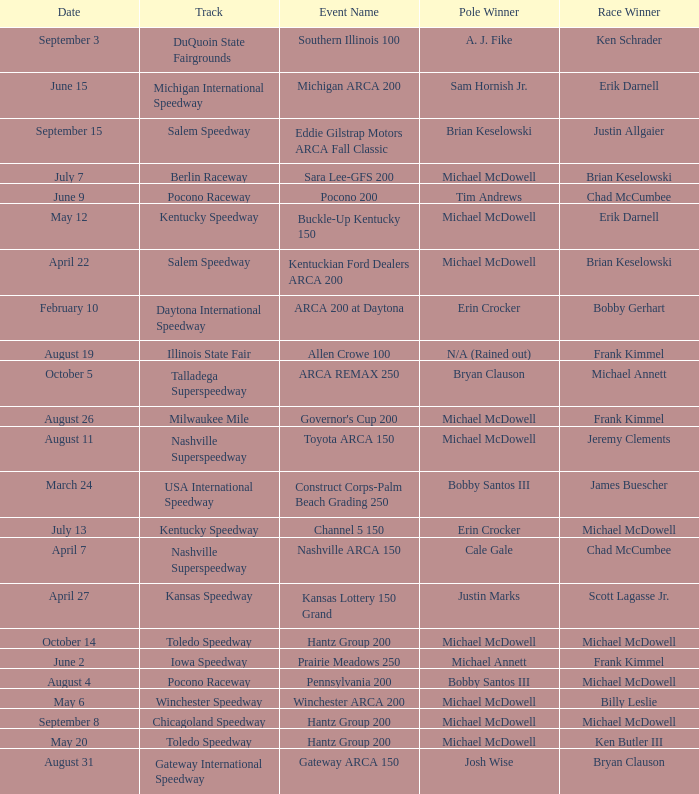Tell me the pole winner of may 12 Michael McDowell. 